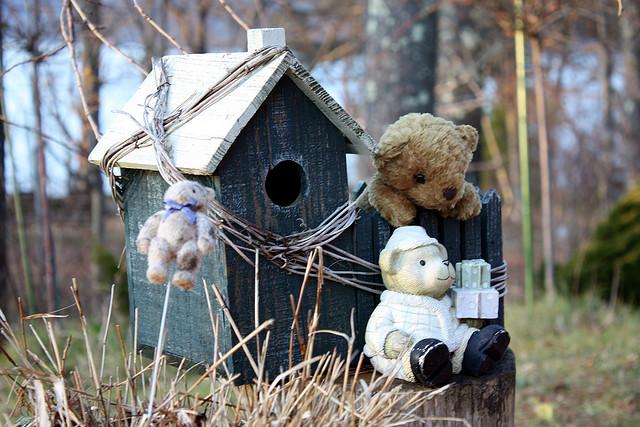What kind of stuffed animal is in the photo?
Be succinct. Bear. Are the bears dangerous?
Short answer required. No. Are the bears inside the house?
Short answer required. No. How many teddy bears are in the picture?
Write a very short answer. 3. 